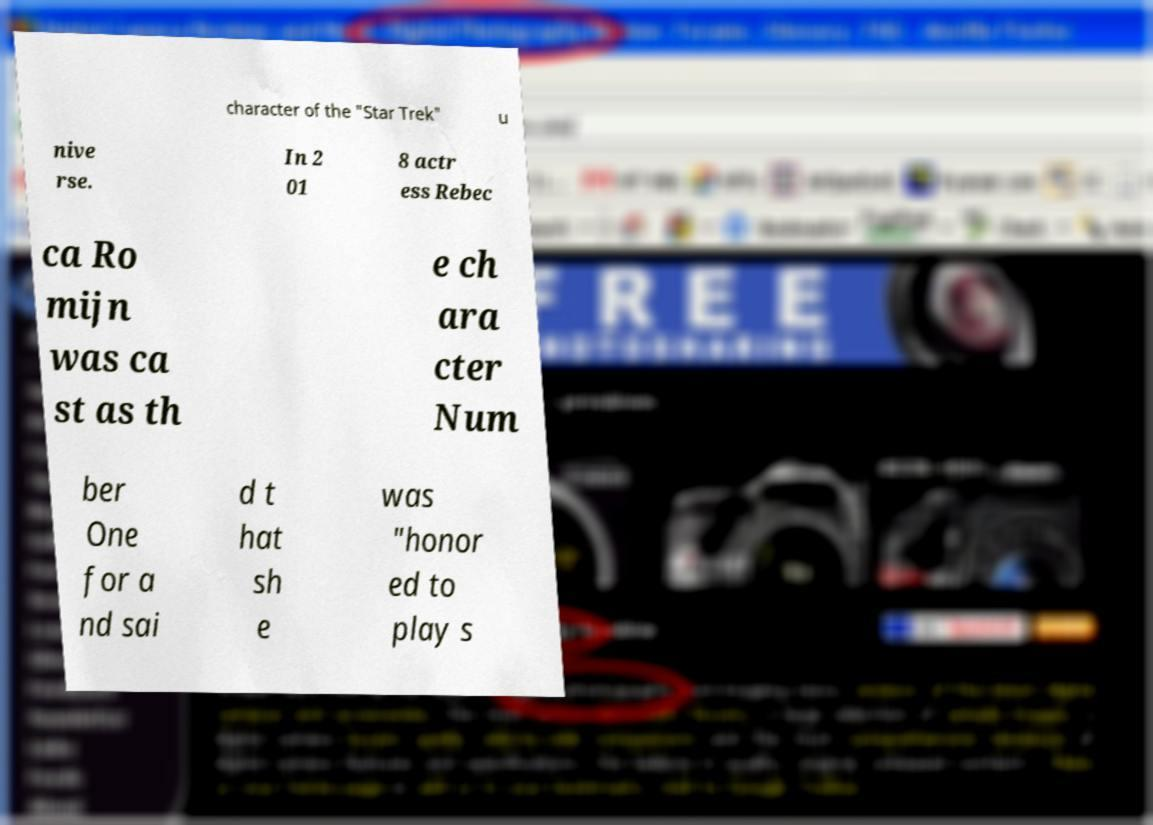Please identify and transcribe the text found in this image. character of the "Star Trek" u nive rse. In 2 01 8 actr ess Rebec ca Ro mijn was ca st as th e ch ara cter Num ber One for a nd sai d t hat sh e was "honor ed to play s 